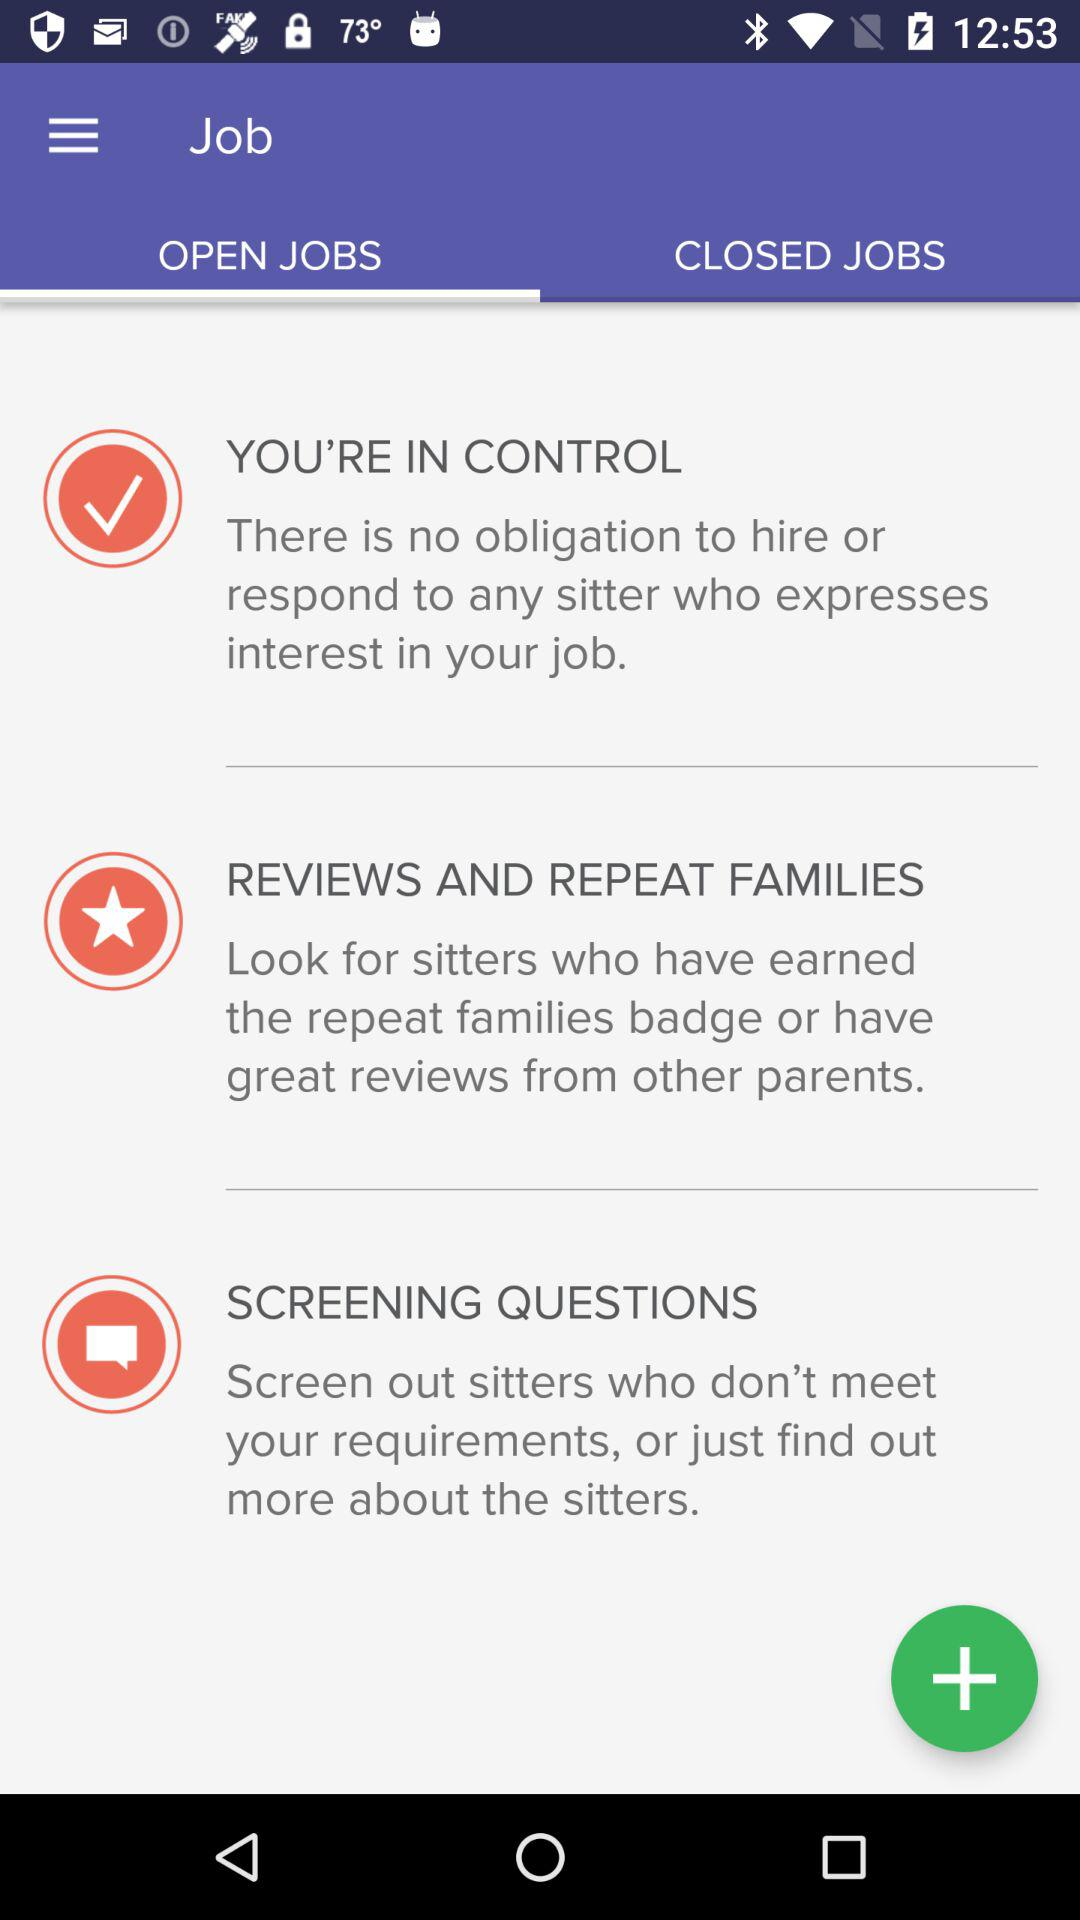Which tab is selected? The selected tab is "OPEN JOBS". 